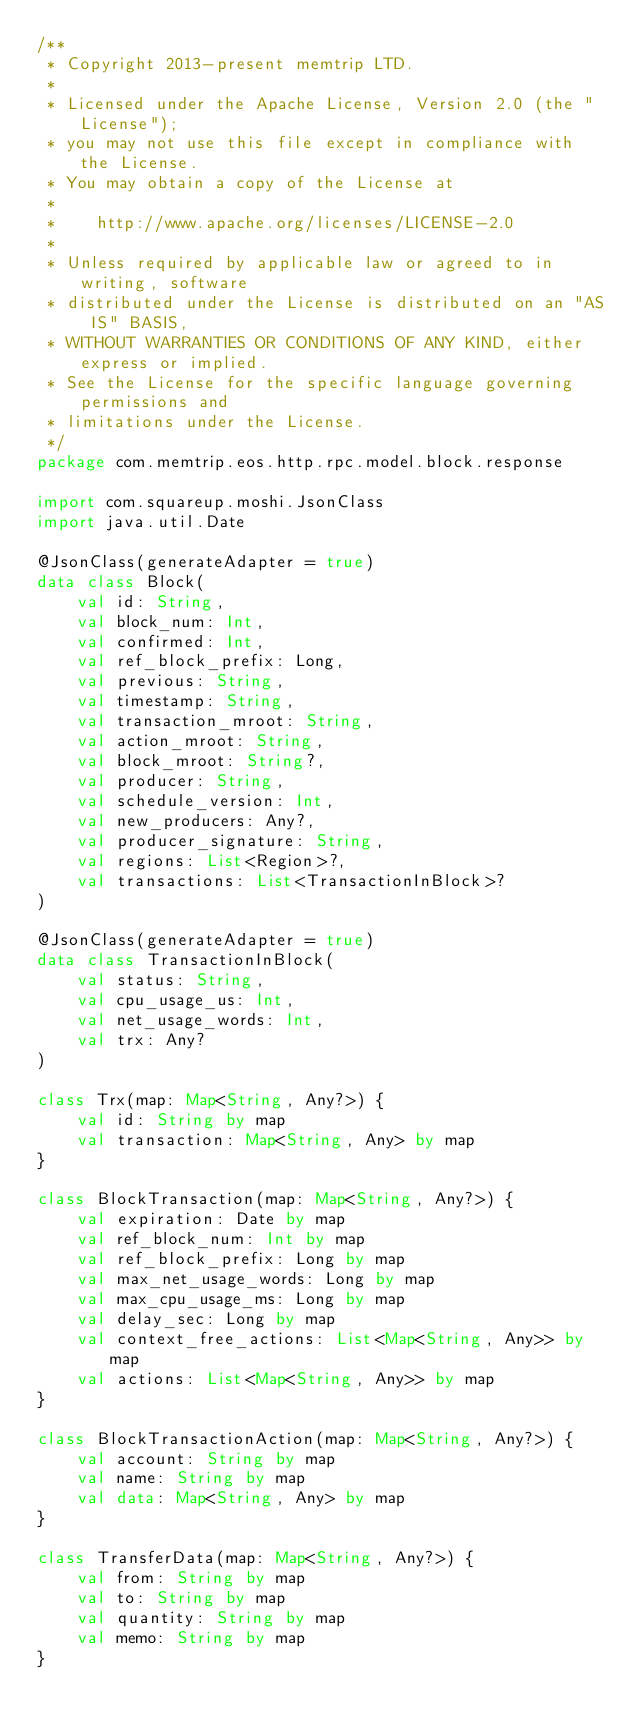Convert code to text. <code><loc_0><loc_0><loc_500><loc_500><_Kotlin_>/**
 * Copyright 2013-present memtrip LTD.
 *
 * Licensed under the Apache License, Version 2.0 (the "License");
 * you may not use this file except in compliance with the License.
 * You may obtain a copy of the License at
 *
 *    http://www.apache.org/licenses/LICENSE-2.0
 *
 * Unless required by applicable law or agreed to in writing, software
 * distributed under the License is distributed on an "AS IS" BASIS,
 * WITHOUT WARRANTIES OR CONDITIONS OF ANY KIND, either express or implied.
 * See the License for the specific language governing permissions and
 * limitations under the License.
 */
package com.memtrip.eos.http.rpc.model.block.response

import com.squareup.moshi.JsonClass
import java.util.Date

@JsonClass(generateAdapter = true)
data class Block(
    val id: String,
    val block_num: Int,
    val confirmed: Int,
    val ref_block_prefix: Long,
    val previous: String,
    val timestamp: String,
    val transaction_mroot: String,
    val action_mroot: String,
    val block_mroot: String?,
    val producer: String,
    val schedule_version: Int,
    val new_producers: Any?,
    val producer_signature: String,
    val regions: List<Region>?,
    val transactions: List<TransactionInBlock>?
)

@JsonClass(generateAdapter = true)
data class TransactionInBlock(
    val status: String,
    val cpu_usage_us: Int,
    val net_usage_words: Int,
    val trx: Any?
)

class Trx(map: Map<String, Any?>) {
    val id: String by map
    val transaction: Map<String, Any> by map
}

class BlockTransaction(map: Map<String, Any?>) {
    val expiration: Date by map
    val ref_block_num: Int by map
    val ref_block_prefix: Long by map
    val max_net_usage_words: Long by map
    val max_cpu_usage_ms: Long by map
    val delay_sec: Long by map
    val context_free_actions: List<Map<String, Any>> by map
    val actions: List<Map<String, Any>> by map
}

class BlockTransactionAction(map: Map<String, Any?>) {
    val account: String by map
    val name: String by map
    val data: Map<String, Any> by map
}

class TransferData(map: Map<String, Any?>) {
    val from: String by map
    val to: String by map
    val quantity: String by map
    val memo: String by map
}</code> 